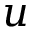<formula> <loc_0><loc_0><loc_500><loc_500>u</formula> 